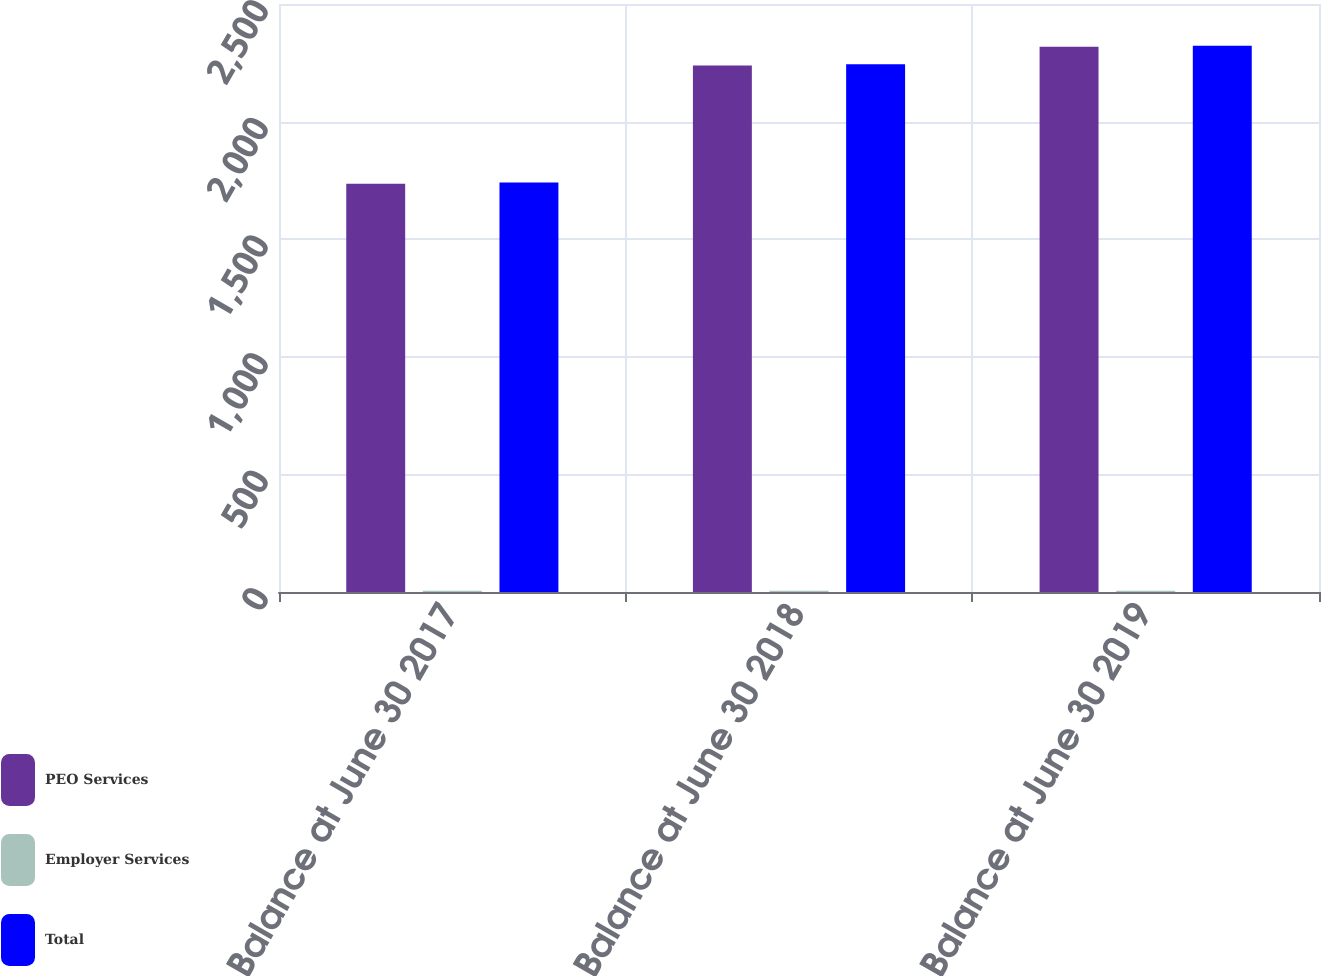Convert chart. <chart><loc_0><loc_0><loc_500><loc_500><stacked_bar_chart><ecel><fcel>Balance at June 30 2017<fcel>Balance at June 30 2018<fcel>Balance at June 30 2019<nl><fcel>PEO Services<fcel>1736.2<fcel>2238.7<fcel>2318.2<nl><fcel>Employer Services<fcel>4.8<fcel>4.8<fcel>4.8<nl><fcel>Total<fcel>1741<fcel>2243.5<fcel>2323<nl></chart> 